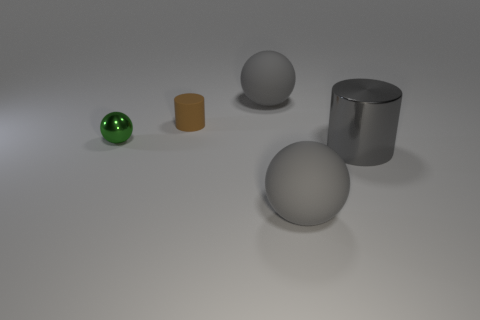Subtract all small green metallic balls. How many balls are left? 2 Add 2 green shiny balls. How many objects exist? 7 Subtract 1 cylinders. How many cylinders are left? 1 Subtract all green balls. How many balls are left? 2 Subtract 1 brown cylinders. How many objects are left? 4 Subtract all cylinders. How many objects are left? 3 Subtract all red spheres. Subtract all brown cubes. How many spheres are left? 3 Subtract all green cubes. How many green balls are left? 1 Subtract all tiny blue metallic objects. Subtract all big gray metal objects. How many objects are left? 4 Add 3 small brown things. How many small brown things are left? 4 